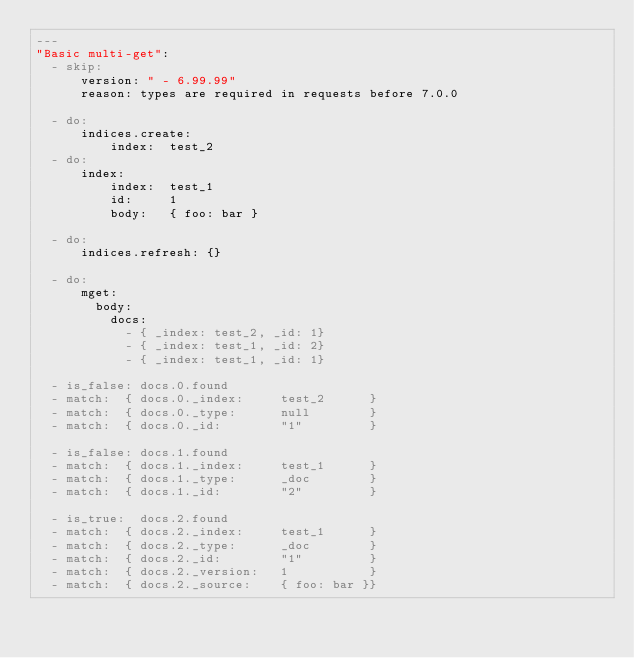<code> <loc_0><loc_0><loc_500><loc_500><_YAML_>---
"Basic multi-get":
  - skip:
      version: " - 6.99.99"
      reason: types are required in requests before 7.0.0

  - do:
      indices.create:
          index:  test_2
  - do:
      index:
          index:  test_1
          id:     1
          body:   { foo: bar }

  - do:
      indices.refresh: {}

  - do:
      mget:
        body:
          docs:
            - { _index: test_2, _id: 1}
            - { _index: test_1, _id: 2}
            - { _index: test_1, _id: 1}

  - is_false: docs.0.found
  - match:  { docs.0._index:     test_2      }
  - match:  { docs.0._type:      null        }
  - match:  { docs.0._id:        "1"         }

  - is_false: docs.1.found
  - match:  { docs.1._index:     test_1      }
  - match:  { docs.1._type:      _doc        }
  - match:  { docs.1._id:        "2"         }

  - is_true:  docs.2.found
  - match:  { docs.2._index:     test_1      }
  - match:  { docs.2._type:      _doc        }
  - match:  { docs.2._id:        "1"         }
  - match:  { docs.2._version:   1           }
  - match:  { docs.2._source:    { foo: bar }}
</code> 